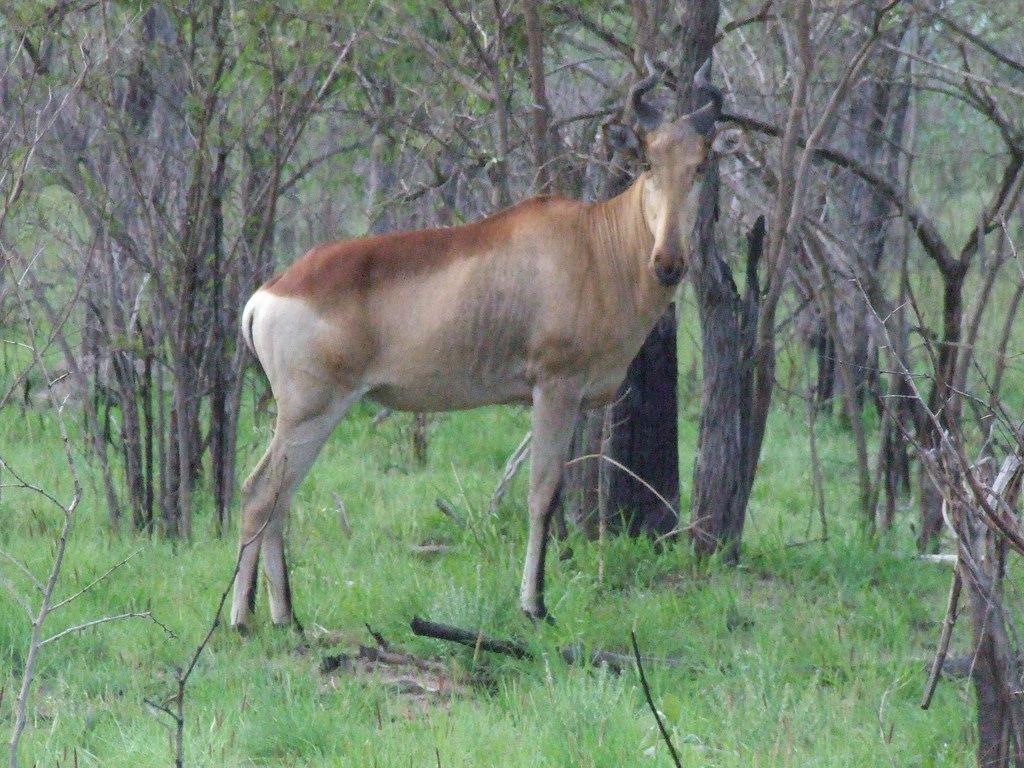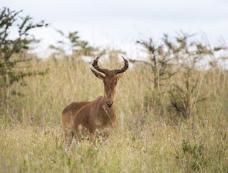The first image is the image on the left, the second image is the image on the right. For the images displayed, is the sentence "Each image contains only one horned animal, and the animals on the left and right are gazing in the same direction." factually correct? Answer yes or no. Yes. The first image is the image on the left, the second image is the image on the right. For the images displayed, is the sentence "The animal in the left image is pointed to the right." factually correct? Answer yes or no. Yes. 